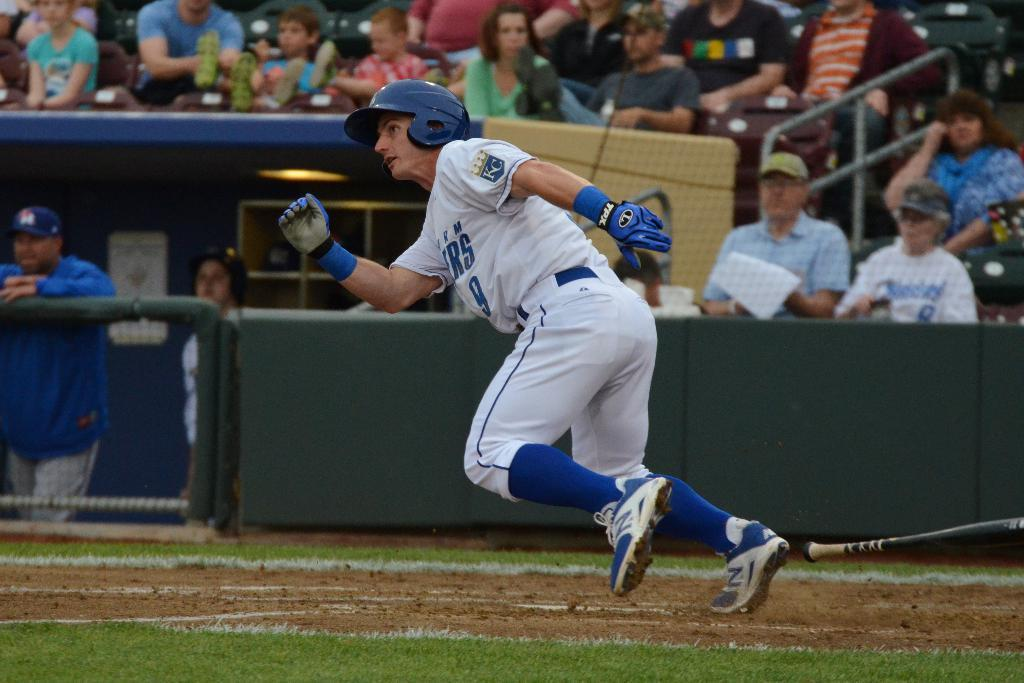What is the main subject of the image? There is a person in the image. What is the person wearing? The person is wearing a white dress. What is the person doing in the image? The person is running. What object can be seen in the right corner of the image? There is a baseball bat in the right corner of the image. What can be seen in the background of the image? There are audience members in the background of the image. Can you tell me how many geese are present in the image? There are no geese present in the image. What type of earth is visible in the image? The image does not show any specific type of earth; it is a photograph of a person running with a baseball bat in the background. 